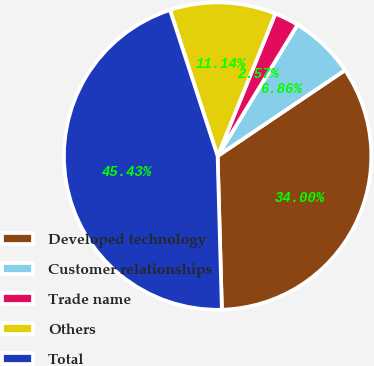<chart> <loc_0><loc_0><loc_500><loc_500><pie_chart><fcel>Developed technology<fcel>Customer relationships<fcel>Trade name<fcel>Others<fcel>Total<nl><fcel>34.0%<fcel>6.86%<fcel>2.57%<fcel>11.14%<fcel>45.43%<nl></chart> 